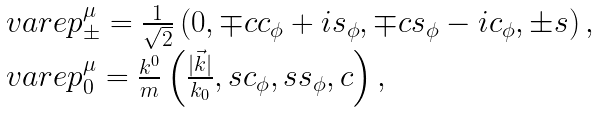Convert formula to latex. <formula><loc_0><loc_0><loc_500><loc_500>\begin{array} { l } \ v a r e p _ { \pm } ^ { \mu } = \frac { 1 } { \sqrt { 2 } } \left ( 0 , \mp c c _ { \phi } + i s _ { \phi } , \mp c s _ { \phi } - i c _ { \phi } , \pm s \right ) , \\ \ v a r e p _ { 0 } ^ { \mu } = \frac { k ^ { 0 } } { m } \left ( \frac { | \vec { k } | } { k _ { 0 } } , s c _ { \phi } , s s _ { \phi } , c \right ) , \end{array}</formula> 